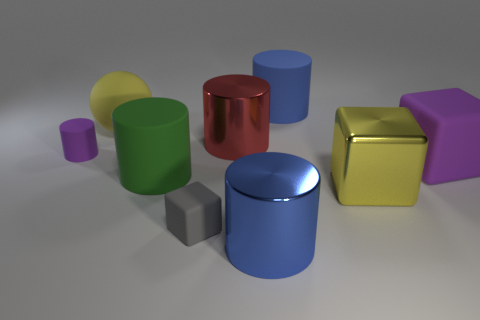Subtract 1 cylinders. How many cylinders are left? 4 Subtract all tiny purple rubber cylinders. How many cylinders are left? 4 Subtract all cyan cylinders. Subtract all blue balls. How many cylinders are left? 5 Add 1 blue cylinders. How many objects exist? 10 Subtract all cylinders. How many objects are left? 4 Add 4 large purple matte blocks. How many large purple matte blocks exist? 5 Subtract 0 gray balls. How many objects are left? 9 Subtract all blue rubber objects. Subtract all big green matte cylinders. How many objects are left? 7 Add 4 tiny matte cylinders. How many tiny matte cylinders are left? 5 